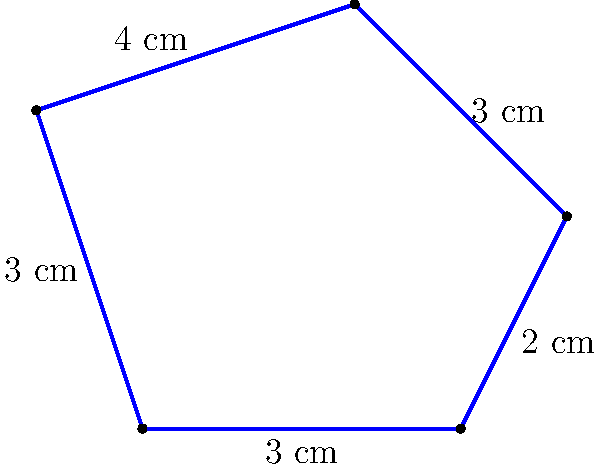You've discovered an antique brooch in your family's heirloom collection. The brooch has an irregular pentagonal shape with the following side lengths: 3 cm, 2 cm, 3 cm, 4 cm, and 3 cm. Calculate the perimeter of this unique piece. To calculate the perimeter of the irregularly shaped antique brooch, we need to sum up the lengths of all its sides. Let's break it down step by step:

1. Identify the side lengths:
   - Side 1: 3 cm
   - Side 2: 2 cm
   - Side 3: 3 cm
   - Side 4: 4 cm
   - Side 5: 3 cm

2. Set up the perimeter formula:
   $$ \text{Perimeter} = \text{Side 1} + \text{Side 2} + \text{Side 3} + \text{Side 4} + \text{Side 5} $$

3. Substitute the values:
   $$ \text{Perimeter} = 3 \text{ cm} + 2 \text{ cm} + 3 \text{ cm} + 4 \text{ cm} + 3 \text{ cm} $$

4. Perform the addition:
   $$ \text{Perimeter} = 15 \text{ cm} $$

Therefore, the perimeter of the antique brooch is 15 cm.
Answer: 15 cm 